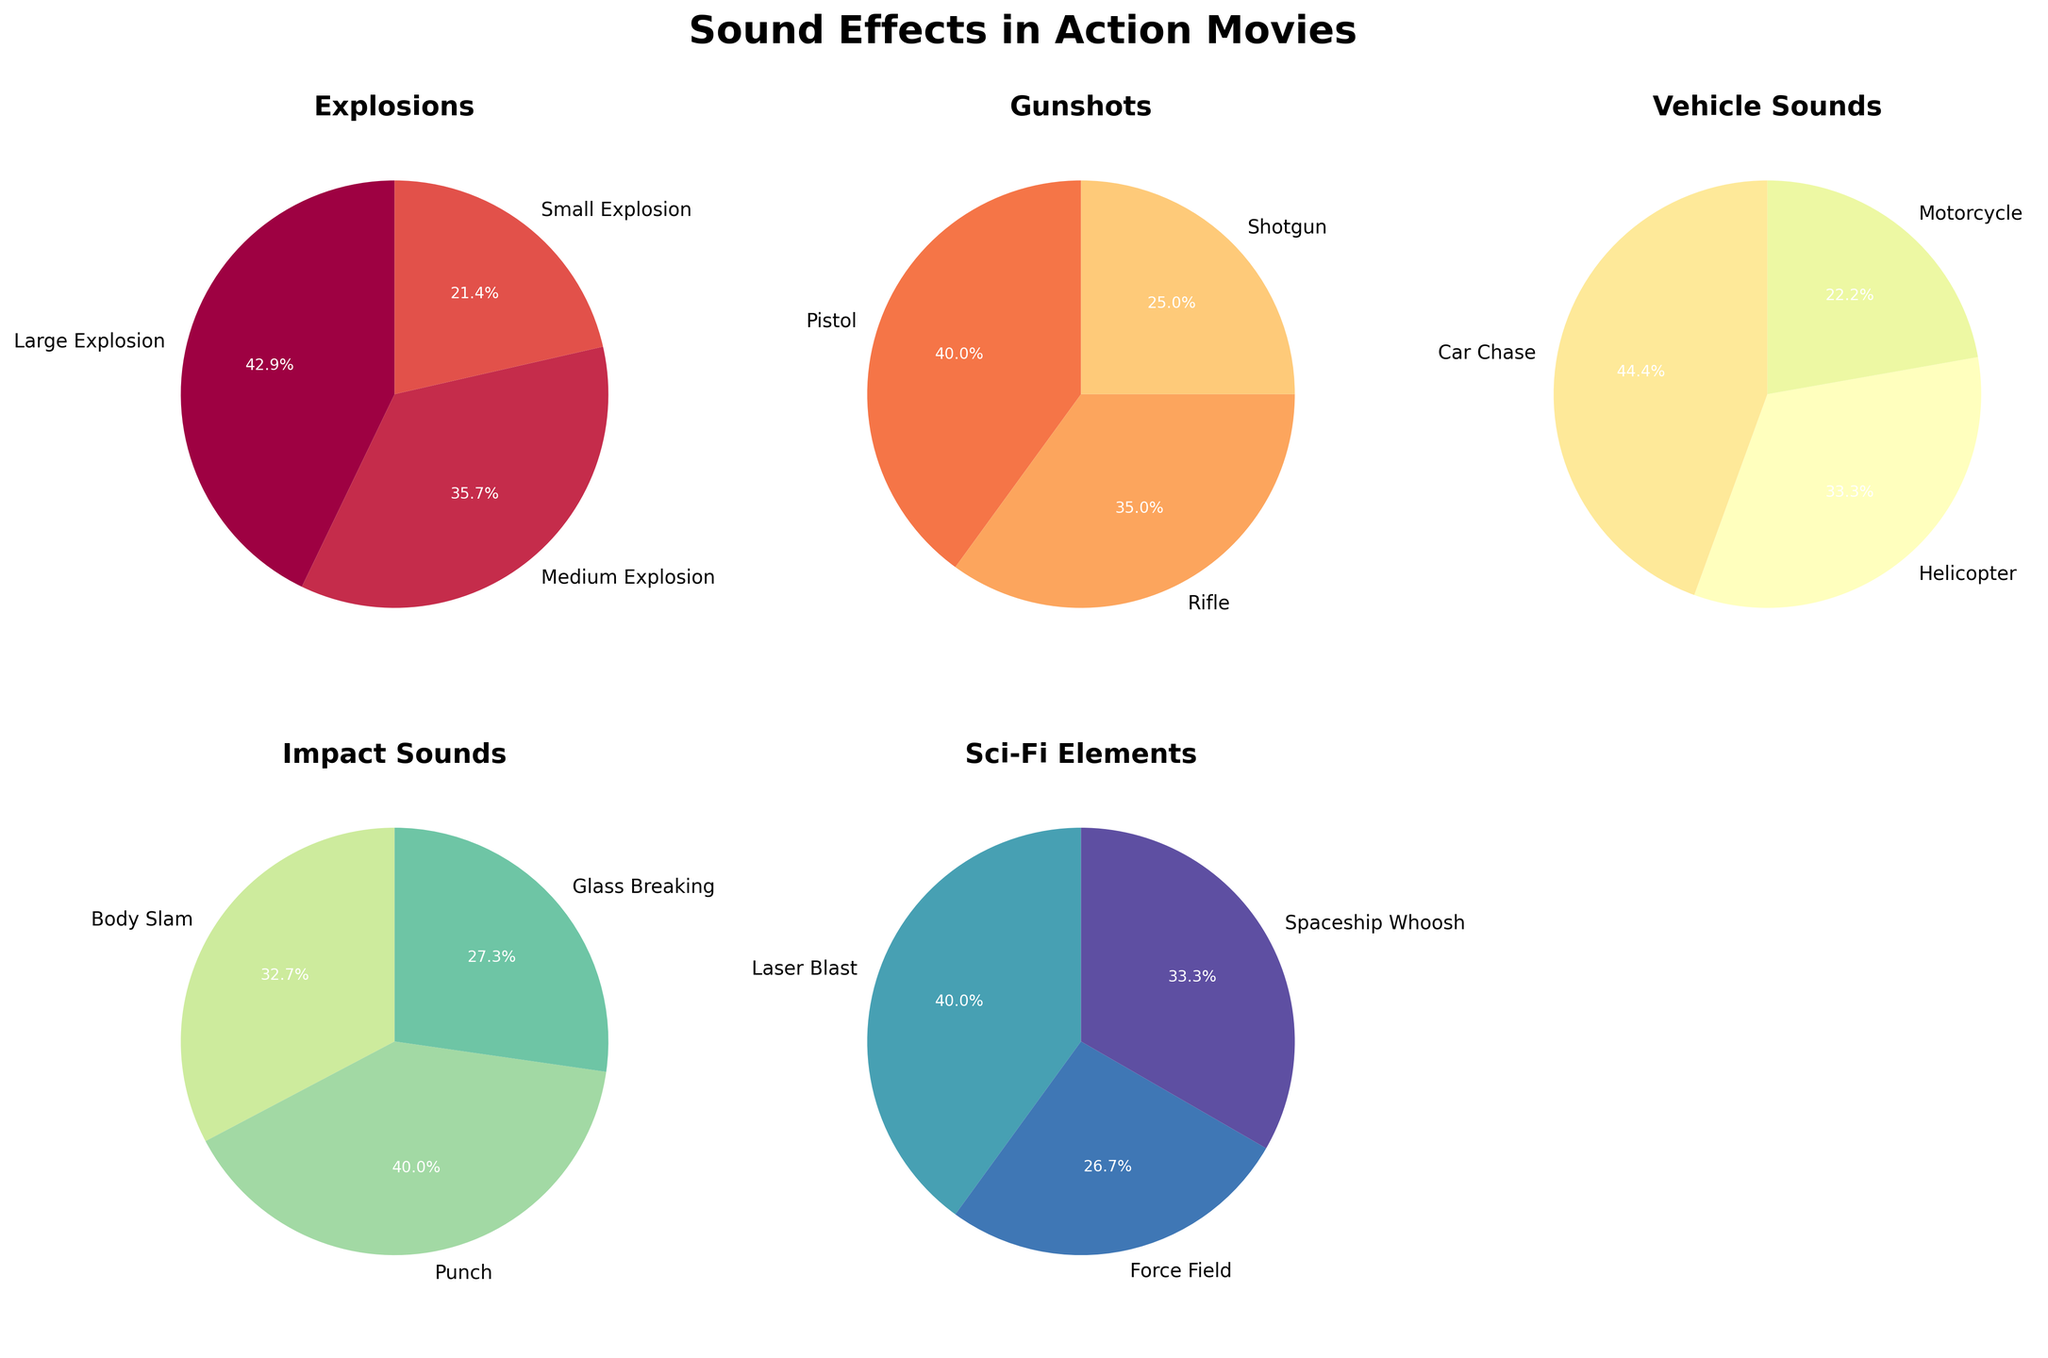What's the title of the figure? The figure's title is displayed at the top in large, bold font.
Answer: Sound Effects in Action Movies Which category has the most frequent sound effect? To determine this, look at the pie charts for each category and find the segment with the highest percentage. The 'Pistol' effect in the Gunshots category has the highest frequency at 40%.
Answer: Gunshots What percentage of sound effects are explosions? To answer this, add the percentages of the 'Large Explosion', 'Medium Explosion', and 'Small Explosion' segments. This is (30 + 25 + 15) = 70%.
Answer: 70% How does the frequency of 'Laser Blast' compare to 'Force Field'? Locate the segments for 'Laser Blast' and 'Force Field' in the Sci-Fi Elements pie chart and compare their percentages. 'Laser Blast' is 12%, and 'Force Field' is 8%.
Answer: Laser Blast is more frequent Which effect in the Vehicle Sounds category occurs the least? Look at the pie chart for Vehicle Sounds and identify the smallest segment. The 'Motorcycle' effect has the smallest percentage at 10%.
Answer: Motorcycle What is the combined frequency of 'Punch' and 'Body Slam' sound effects? Add the percentages for 'Punch' and 'Body Slam' from the Impact Sounds pie chart. This is (22 + 18) = 40%.
Answer: 40% Which category has the smallest variety of sound effects? Count the number of segments in each pie chart. The Sci-Fi Elements category has the least variety with three effects.
Answer: Sci-Fi Elements What is the average frequency of sound effects within the Explosions category? Add the frequencies for the three effects in the Explosions category and divide by 3. This is (30 + 25 + 15) / 3 = 70 / 3 ≈ 23.3%.
Answer: 23.3% Are there more gunshot sound effects or vehicle sound effects? Sum the frequencies for the Gunshots category and the Vehicle Sounds category. Gunshots total (40 + 35 + 25) = 100%; Vehicle Sounds total (20 + 15 + 10) = 45%. Gunshots have more effects.
Answer: Gunshots Which sound effect in the Impact Sounds category has the highest frequency? Look at the pie chart for Impact Sounds and find the segment with the highest percentage. The 'Punch' effect has the highest frequency at 22%.
Answer: Punch 